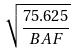Convert formula to latex. <formula><loc_0><loc_0><loc_500><loc_500>\sqrt { \frac { 7 5 . 6 2 5 } { B A F } }</formula> 